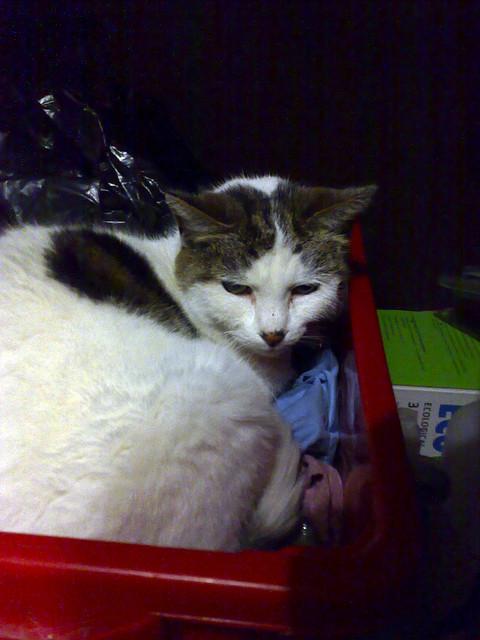Do pet owners often find that this type of animal likes to squeeze itself into tight spaces?
Keep it brief. Yes. Does this cat look happy?
Give a very brief answer. No. How many things are in the luggage?
Quick response, please. 1. Is the cat alert?
Quick response, please. No. What color is the box that the cat is in?
Concise answer only. Red. 